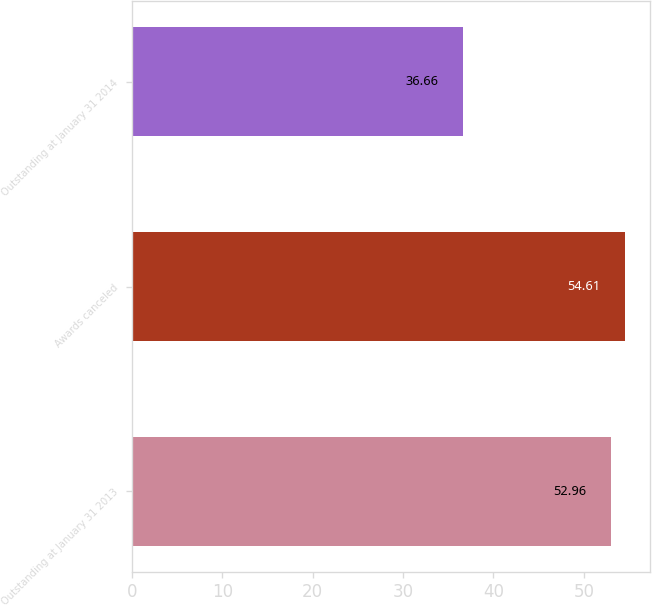Convert chart. <chart><loc_0><loc_0><loc_500><loc_500><bar_chart><fcel>Outstanding at January 31 2013<fcel>Awards canceled<fcel>Outstanding at January 31 2014<nl><fcel>52.96<fcel>54.61<fcel>36.66<nl></chart> 